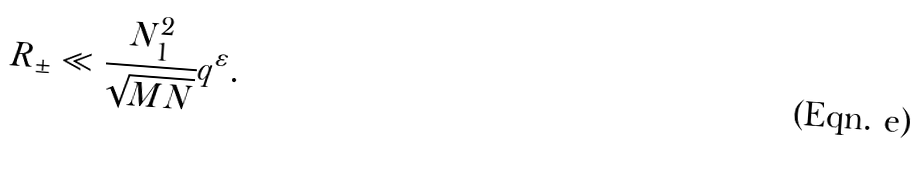<formula> <loc_0><loc_0><loc_500><loc_500>R _ { \pm } \ll \frac { N _ { 1 } ^ { 2 } } { \sqrt { M N } } q ^ { \varepsilon } .</formula> 